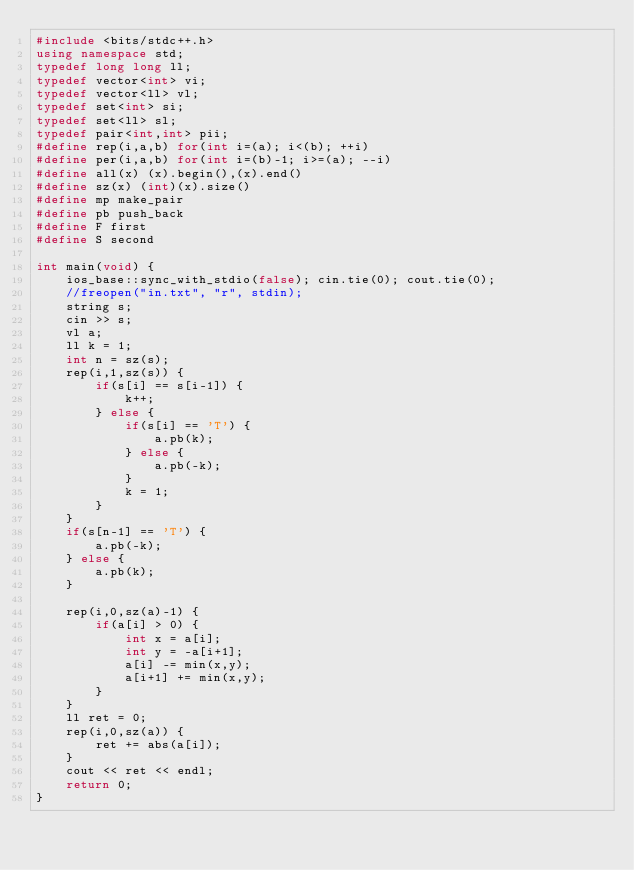<code> <loc_0><loc_0><loc_500><loc_500><_C++_>#include <bits/stdc++.h>
using namespace std;
typedef long long ll;
typedef vector<int> vi;
typedef vector<ll> vl;
typedef set<int> si;
typedef set<ll> sl;
typedef pair<int,int> pii;
#define rep(i,a,b) for(int i=(a); i<(b); ++i)
#define per(i,a,b) for(int i=(b)-1; i>=(a); --i)
#define all(x) (x).begin(),(x).end()
#define sz(x) (int)(x).size()
#define mp make_pair
#define pb push_back
#define F first
#define S second

int main(void) {
    ios_base::sync_with_stdio(false); cin.tie(0); cout.tie(0);
    //freopen("in.txt", "r", stdin);
    string s;
    cin >> s;
    vl a;
    ll k = 1;
    int n = sz(s);
    rep(i,1,sz(s)) {
        if(s[i] == s[i-1]) {
            k++;
        } else {
            if(s[i] == 'T') {
                a.pb(k);
            } else {
                a.pb(-k);
            }
            k = 1;
        }
    }
    if(s[n-1] == 'T') {
        a.pb(-k);
    } else {
        a.pb(k);
    }

    rep(i,0,sz(a)-1) {
        if(a[i] > 0) {
            int x = a[i];
            int y = -a[i+1];
            a[i] -= min(x,y);
            a[i+1] += min(x,y);
        }
    }
    ll ret = 0;
    rep(i,0,sz(a)) {
        ret += abs(a[i]);
    }
    cout << ret << endl;
    return 0;
}
</code> 